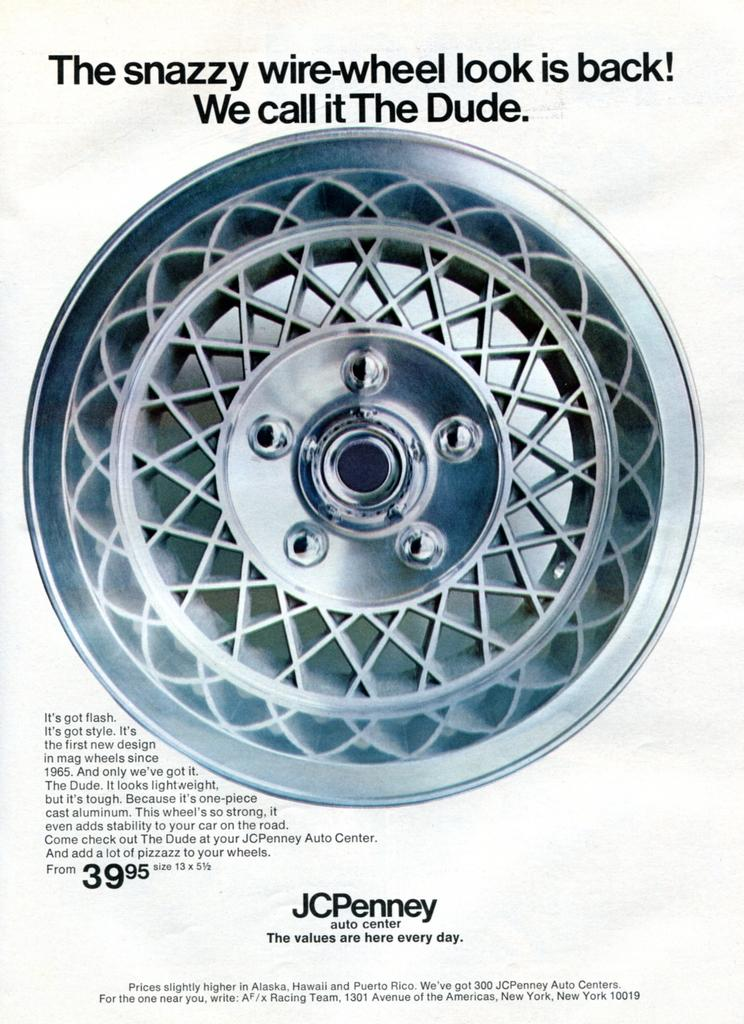What is the main object in the center of the image? There is a wheel in the center of the image. What can be seen at the top of the image? There is text at the top of the image. What is located at the bottom of the image? There is text at the bottom of the image. What idea or discovery is depicted on the page in the image? There is no page present in the image; it features a wheel and text. 